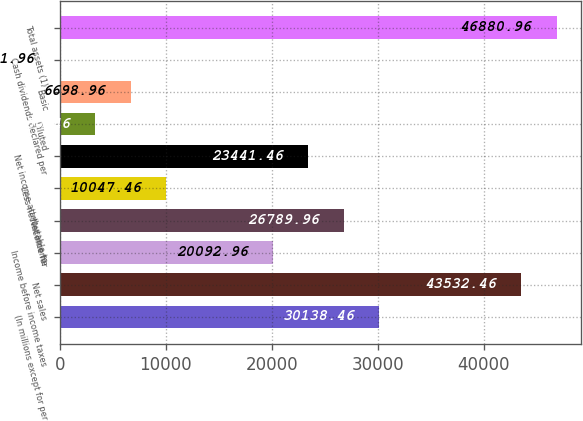Convert chart to OTSL. <chart><loc_0><loc_0><loc_500><loc_500><bar_chart><fcel>(In millions except for per<fcel>Net sales<fcel>Income before income taxes<fcel>Net income<fcel>Less net income for<fcel>Net income attributable to<fcel>Diluted<fcel>Basic<fcel>Cash dividends declared per<fcel>Total assets (1)<nl><fcel>30138.5<fcel>43532.5<fcel>20093<fcel>26790<fcel>10047.5<fcel>23441.5<fcel>3350.46<fcel>6698.96<fcel>1.96<fcel>46881<nl></chart> 